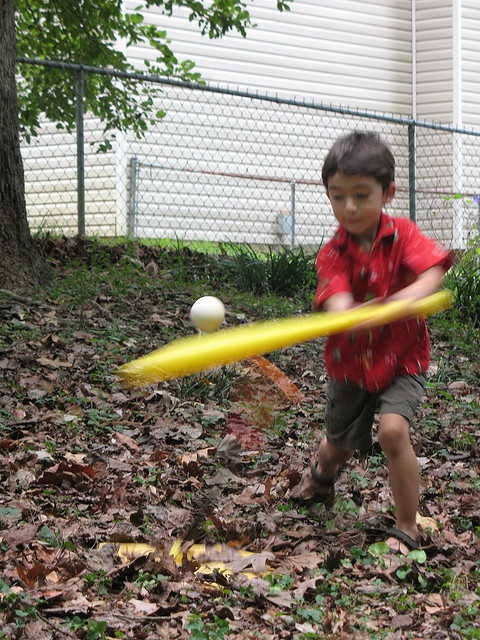Describe the objects in this image and their specific colors. I can see people in black, maroon, and gray tones, baseball bat in black, khaki, olive, and gold tones, and sports ball in black, white, olive, darkgray, and lightgray tones in this image. 